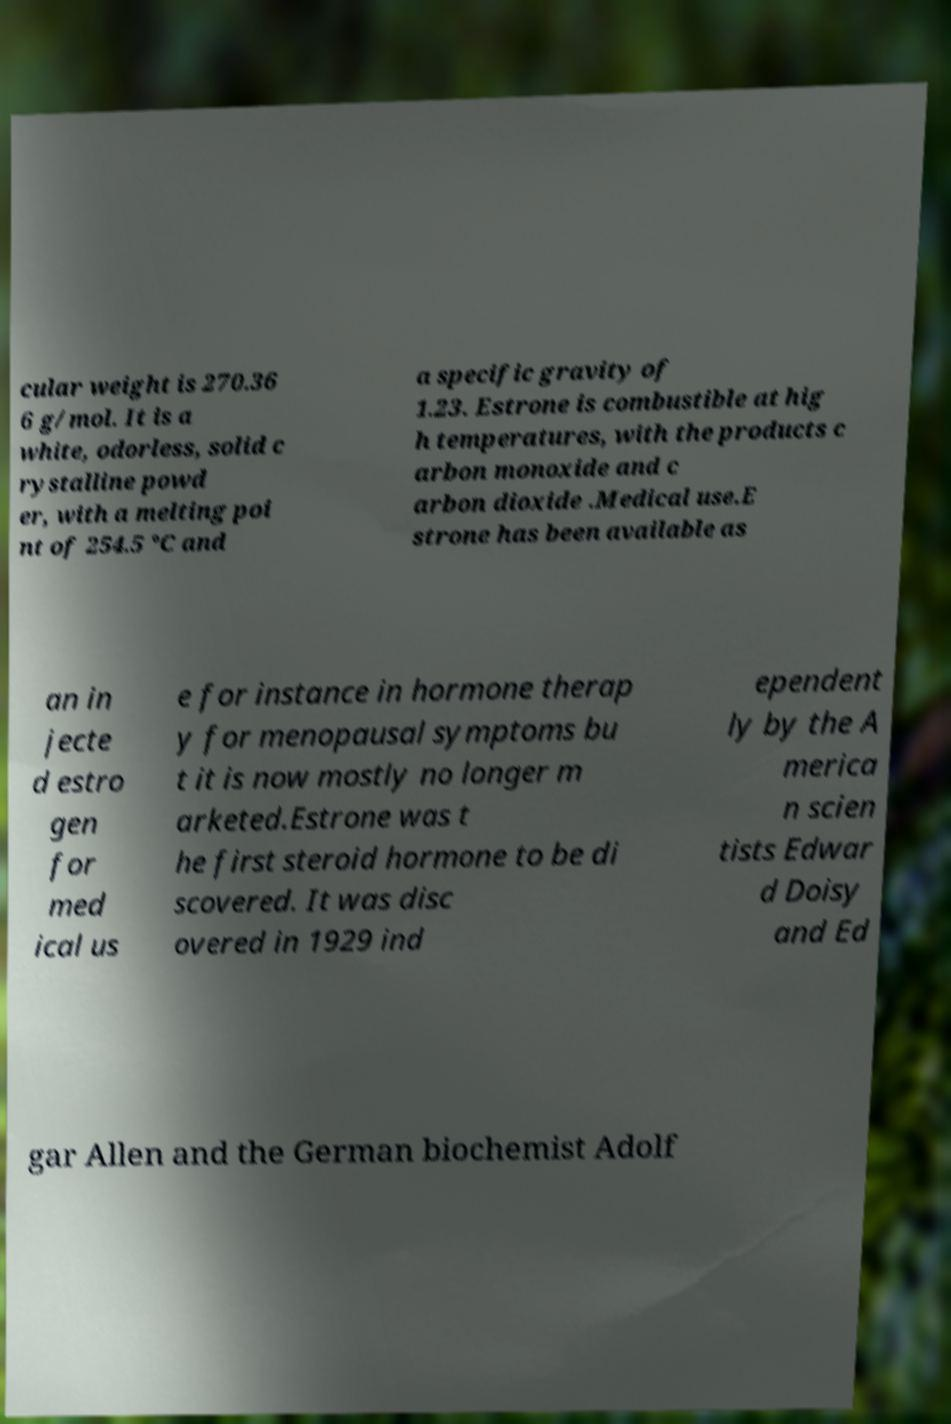I need the written content from this picture converted into text. Can you do that? cular weight is 270.36 6 g/mol. It is a white, odorless, solid c rystalline powd er, with a melting poi nt of 254.5 °C and a specific gravity of 1.23. Estrone is combustible at hig h temperatures, with the products c arbon monoxide and c arbon dioxide .Medical use.E strone has been available as an in jecte d estro gen for med ical us e for instance in hormone therap y for menopausal symptoms bu t it is now mostly no longer m arketed.Estrone was t he first steroid hormone to be di scovered. It was disc overed in 1929 ind ependent ly by the A merica n scien tists Edwar d Doisy and Ed gar Allen and the German biochemist Adolf 